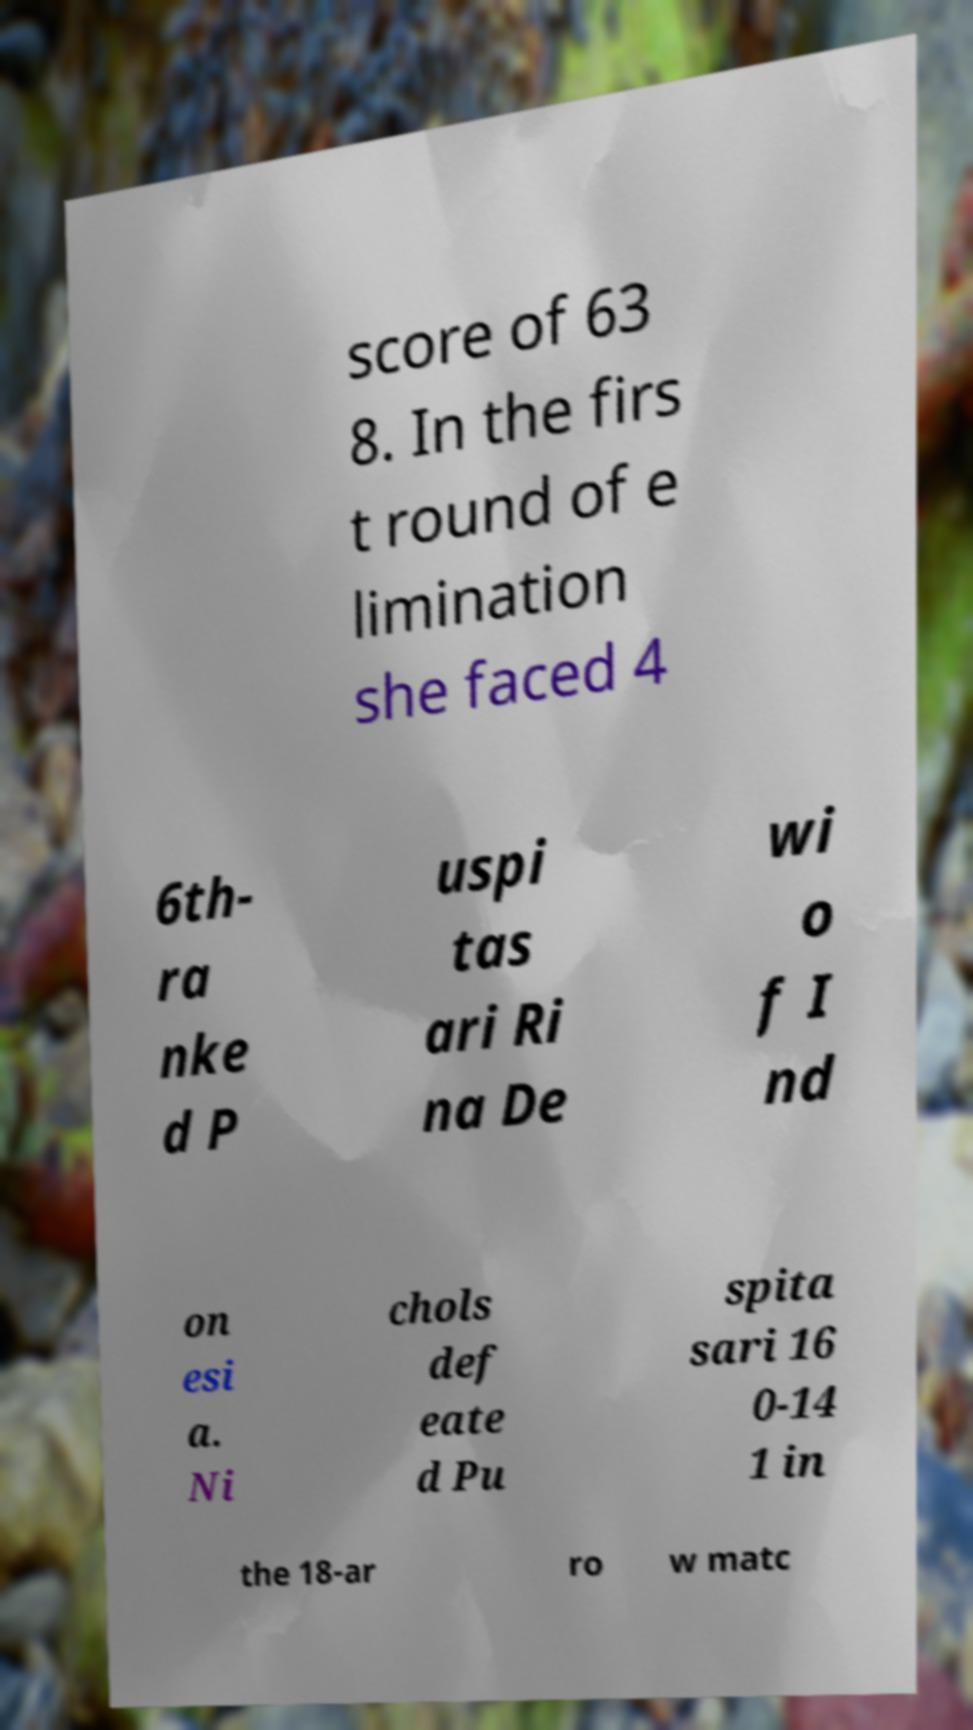Could you extract and type out the text from this image? score of 63 8. In the firs t round of e limination she faced 4 6th- ra nke d P uspi tas ari Ri na De wi o f I nd on esi a. Ni chols def eate d Pu spita sari 16 0-14 1 in the 18-ar ro w matc 